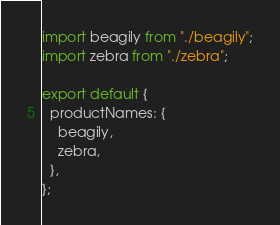Convert code to text. <code><loc_0><loc_0><loc_500><loc_500><_TypeScript_>import beagily from "./beagily";
import zebra from "./zebra";

export default {
  productNames: {
    beagily,
    zebra,
  },
};
</code> 